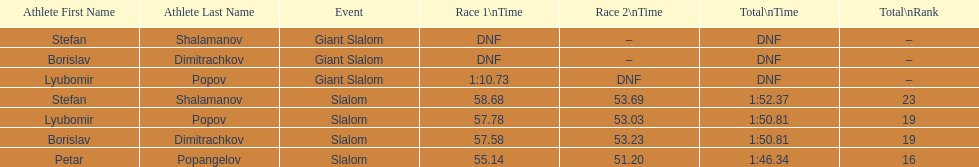Which athletes had consecutive times under 58 for both races? Lyubomir Popov, Borislav Dimitrachkov, Petar Popangelov. Would you mind parsing the complete table? {'header': ['Athlete First Name', 'Athlete Last Name', 'Event', 'Race 1\\nTime', 'Race 2\\nTime', 'Total\\nTime', 'Total\\nRank'], 'rows': [['Stefan', 'Shalamanov', 'Giant Slalom', 'DNF', '–', 'DNF', '–'], ['Borislav', 'Dimitrachkov', 'Giant Slalom', 'DNF', '–', 'DNF', '–'], ['Lyubomir', 'Popov', 'Giant Slalom', '1:10.73', 'DNF', 'DNF', '–'], ['Stefan', 'Shalamanov', 'Slalom', '58.68', '53.69', '1:52.37', '23'], ['Lyubomir', 'Popov', 'Slalom', '57.78', '53.03', '1:50.81', '19'], ['Borislav', 'Dimitrachkov', 'Slalom', '57.58', '53.23', '1:50.81', '19'], ['Petar', 'Popangelov', 'Slalom', '55.14', '51.20', '1:46.34', '16']]} 